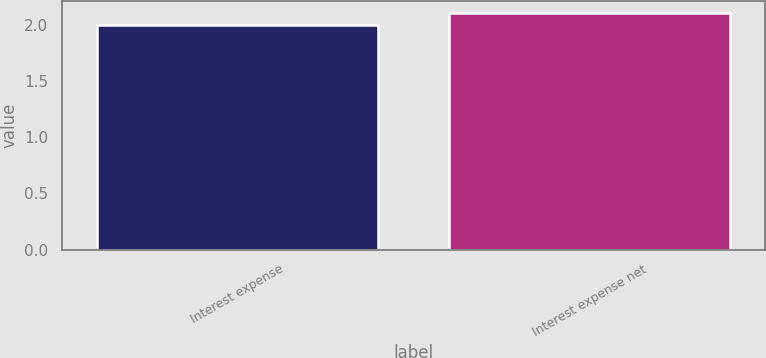<chart> <loc_0><loc_0><loc_500><loc_500><bar_chart><fcel>Interest expense<fcel>Interest expense net<nl><fcel>2<fcel>2.1<nl></chart> 